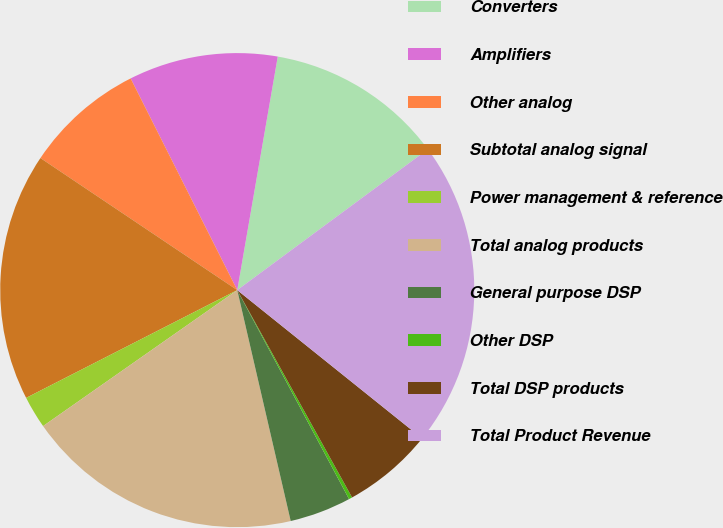Convert chart to OTSL. <chart><loc_0><loc_0><loc_500><loc_500><pie_chart><fcel>Converters<fcel>Amplifiers<fcel>Other analog<fcel>Subtotal analog signal<fcel>Power management & reference<fcel>Total analog products<fcel>General purpose DSP<fcel>Other DSP<fcel>Total DSP products<fcel>Total Product Revenue<nl><fcel>12.14%<fcel>10.16%<fcel>8.17%<fcel>16.92%<fcel>2.21%<fcel>18.9%<fcel>4.2%<fcel>0.23%<fcel>6.19%<fcel>20.89%<nl></chart> 